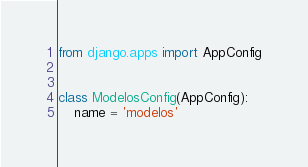Convert code to text. <code><loc_0><loc_0><loc_500><loc_500><_Python_>from django.apps import AppConfig


class ModelosConfig(AppConfig):
    name = 'modelos'
</code> 